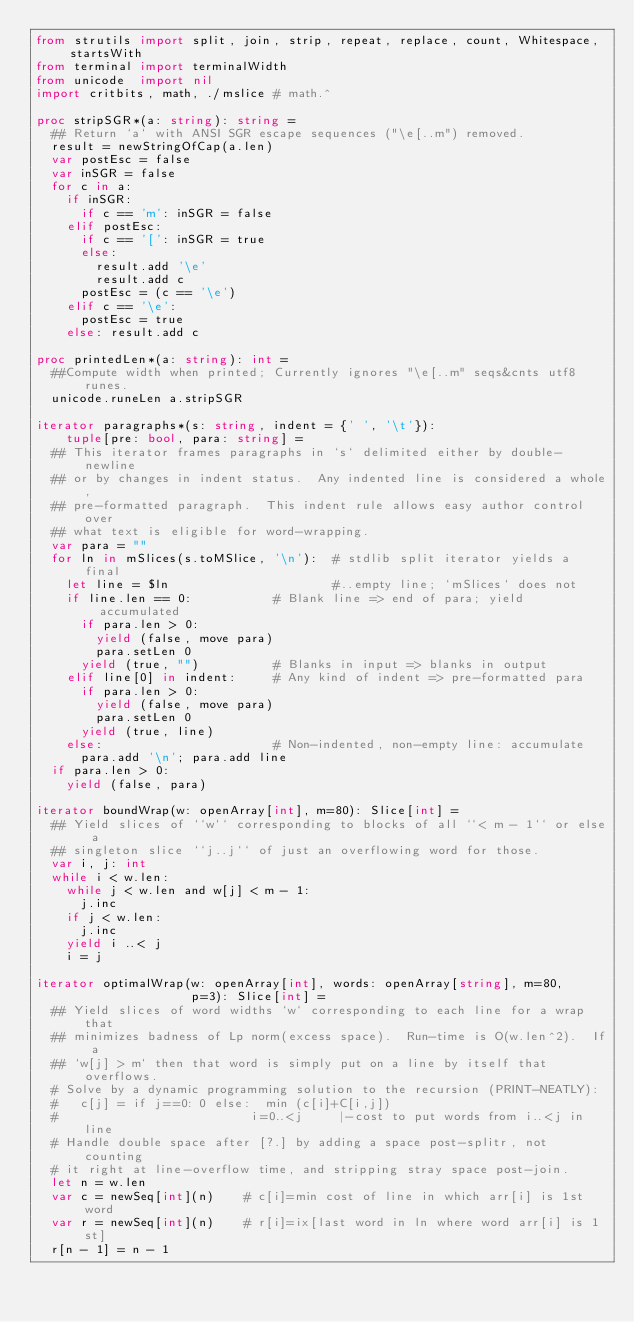Convert code to text. <code><loc_0><loc_0><loc_500><loc_500><_Nim_>from strutils import split, join, strip, repeat, replace, count, Whitespace, startsWith
from terminal import terminalWidth
from unicode  import nil
import critbits, math, ./mslice # math.^

proc stripSGR*(a: string): string =
  ## Return `a` with ANSI SGR escape sequences ("\e[..m") removed.
  result = newStringOfCap(a.len)
  var postEsc = false
  var inSGR = false
  for c in a:
    if inSGR:
      if c == 'm': inSGR = false
    elif postEsc:
      if c == '[': inSGR = true
      else:
        result.add '\e'
        result.add c
      postEsc = (c == '\e')
    elif c == '\e':
      postEsc = true
    else: result.add c

proc printedLen*(a: string): int =
  ##Compute width when printed; Currently ignores "\e[..m" seqs&cnts utf8 runes.
  unicode.runeLen a.stripSGR

iterator paragraphs*(s: string, indent = {' ', '\t'}):
    tuple[pre: bool, para: string] =
  ## This iterator frames paragraphs in `s` delimited either by double-newline
  ## or by changes in indent status.  Any indented line is considered a whole,
  ## pre-formatted paragraph.  This indent rule allows easy author control over
  ## what text is eligible for word-wrapping.
  var para = ""
  for ln in mSlices(s.toMSlice, '\n'):  # stdlib split iterator yields a final
    let line = $ln                      #..empty line; `mSlices` does not
    if line.len == 0:           # Blank line => end of para; yield accumulated
      if para.len > 0:
        yield (false, move para)
        para.setLen 0
      yield (true, "")          # Blanks in input => blanks in output
    elif line[0] in indent:     # Any kind of indent => pre-formatted para
      if para.len > 0:
        yield (false, move para)
        para.setLen 0
      yield (true, line)
    else:                       # Non-indented, non-empty line: accumulate
      para.add '\n'; para.add line
  if para.len > 0:
    yield (false, para)

iterator boundWrap(w: openArray[int], m=80): Slice[int] =
  ## Yield slices of ``w`` corresponding to blocks of all ``< m - 1`` or else a
  ## singleton slice ``j..j`` of just an overflowing word for those.
  var i, j: int
  while i < w.len:
    while j < w.len and w[j] < m - 1:
      j.inc
    if j < w.len:
      j.inc
    yield i ..< j
    i = j

iterator optimalWrap(w: openArray[int], words: openArray[string], m=80,
                     p=3): Slice[int] =
  ## Yield slices of word widths `w` corresponding to each line for a wrap that
  ## minimizes badness of Lp norm(excess space).  Run-time is O(w.len^2).  If a
  ## `w[j] > m` then that word is simply put on a line by itself that overflows.
  # Solve by a dynamic programming solution to the recursion (PRINT-NEATLY):
  #   c[j] = if j==0: 0 else:  min (c[i]+C[i,j])
  #                          i=0..<j     |-cost to put words from i..<j in line
  # Handle double space after [?.] by adding a space post-splitr, not counting
  # it right at line-overflow time, and stripping stray space post-join.
  let n = w.len
  var c = newSeq[int](n)    # c[i]=min cost of line in which arr[i] is 1st word
  var r = newSeq[int](n)    # r[i]=ix[last word in ln where word arr[i] is 1st]
  r[n - 1] = n - 1</code> 